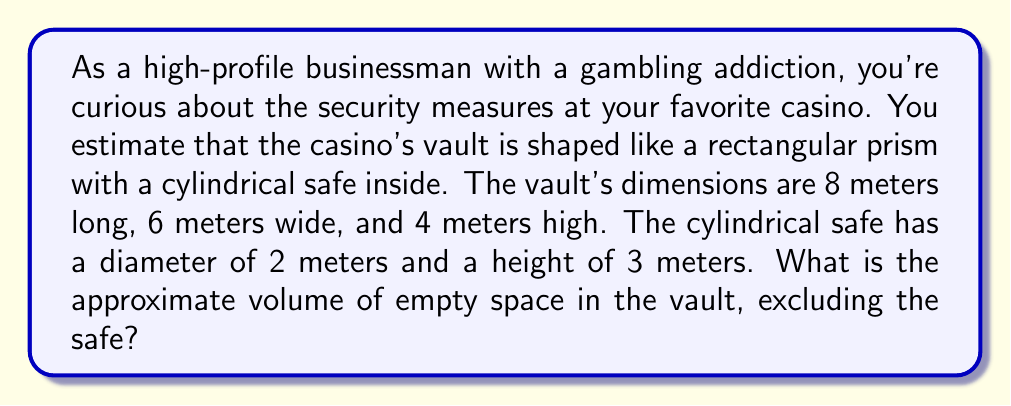Solve this math problem. Let's approach this step-by-step:

1. Calculate the volume of the rectangular vault:
   $$V_{vault} = l \times w \times h = 8 \times 6 \times 4 = 192 \text{ m}^3$$

2. Calculate the volume of the cylindrical safe:
   $$V_{safe} = \pi r^2 h = \pi \times 1^2 \times 3 = 3\pi \text{ m}^3$$

3. Subtract the safe's volume from the vault's volume:
   $$V_{empty} = V_{vault} - V_{safe} = 192 - 3\pi \text{ m}^3$$

4. Simplify:
   $$V_{empty} = 192 - 3\pi \approx 182.56 \text{ m}^3$$

[asy]
import three;

size(200);
currentprojection=perspective(6,3,2);

draw(box((0,0,0),(8,6,4)),blue);
draw(cylinder((4,3,0),1,3),red);

label("8m",(4,6,0),S);
label("6m",(8,3,0),E);
label("4m",(8,6,2),NE);
label("2m",(4,4,0),S);
label("3m",(5,3,1.5),E);
[/asy]
Answer: $182.56 \text{ m}^3$ 